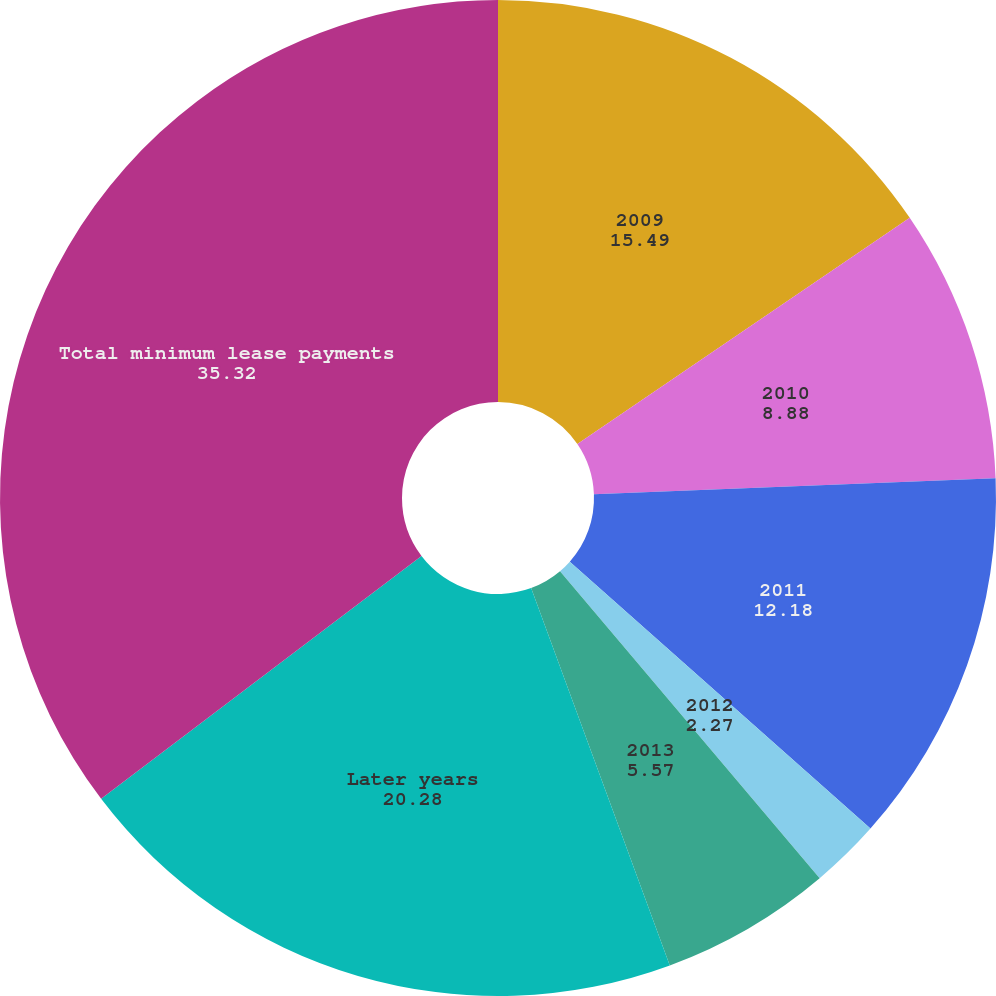<chart> <loc_0><loc_0><loc_500><loc_500><pie_chart><fcel>2009<fcel>2010<fcel>2011<fcel>2012<fcel>2013<fcel>Later years<fcel>Total minimum lease payments<nl><fcel>15.49%<fcel>8.88%<fcel>12.18%<fcel>2.27%<fcel>5.57%<fcel>20.28%<fcel>35.32%<nl></chart> 